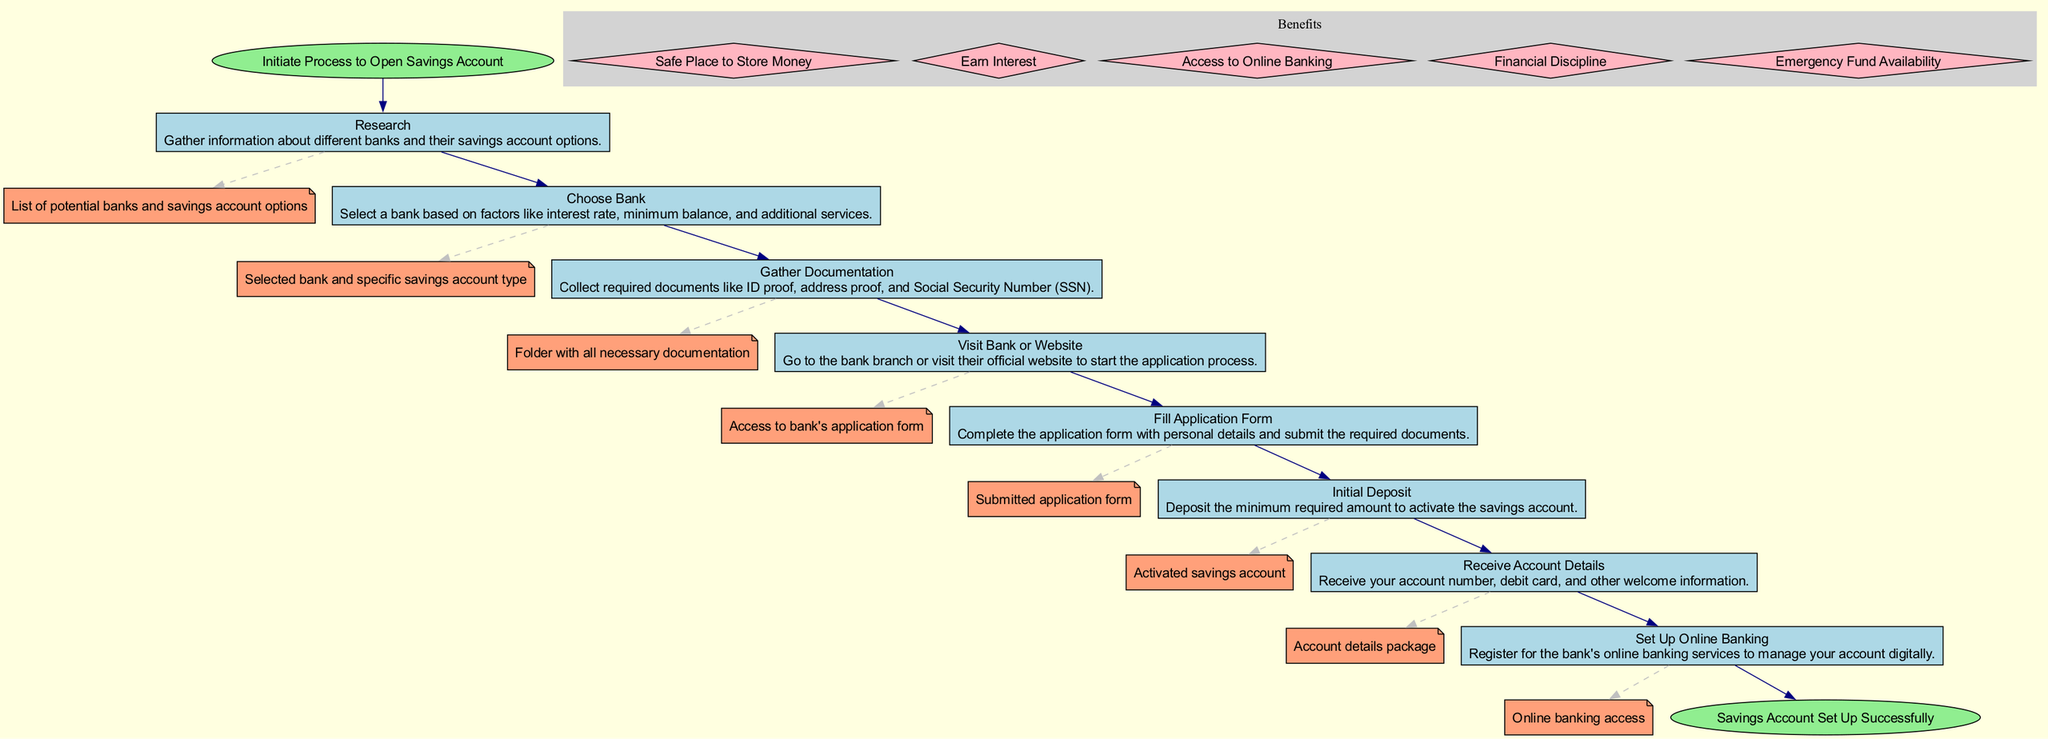What is the first step in this flow chart? The flow chart starts with the node labeled "Start," which initiates the process to open a savings account. The first step that follows is "Research," indicating it is the next action.
Answer: Research How many total steps are there in setting up a savings account? There are eight steps listed in the flow chart, which detail the process from beginning to end.
Answer: Eight What is the output of the "Gather Documentation" step? The output for the "Gather Documentation" step is "Folder with all necessary documentation." This output is linked directly from that particular step in the flow.
Answer: Folder with all necessary documentation Which step comes directly after "Fill Application Form"? After the step "Fill Application Form," the next step in the flow chart is "Initial Deposit." It follows sequentially as indicated by the connecting edge between the two steps.
Answer: Initial Deposit What benefit is associated with having a savings account? One of the benefits listed in the flow chart is "Earn Interest," which highlights the financial advantage of having a savings account. This is one of several benefits shown in that section of the diagram.
Answer: Earn Interest What documentation is needed before visiting the bank? Before visiting the bank, the necessary documentation includes ID proof, address proof, and Social Security Number (SSN), as specified in the "Gather Documentation" step of the flow chart.
Answer: ID proof, address proof, and Social Security Number How does the "Set Up Online Banking" step relate to the previous steps? The "Set Up Online Banking" step occurs after the account is activated, specifically following the "Receive Account Details" step. This shows that online banking is set up as a final management tool for the account.
Answer: After the account is activated What type of graph is this? This is a flow chart, which visually represents a function or a process through a sequence of steps and their interconnections. It illustrates the step-by-step function of setting up a savings account.
Answer: Flow chart 